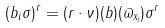<formula> <loc_0><loc_0><loc_500><loc_500>( b _ { i } \sigma ) ^ { r } = ( r \cdot \nu ) ( b ) ( \varpi _ { x _ { i } } ) \sigma ^ { r }</formula> 